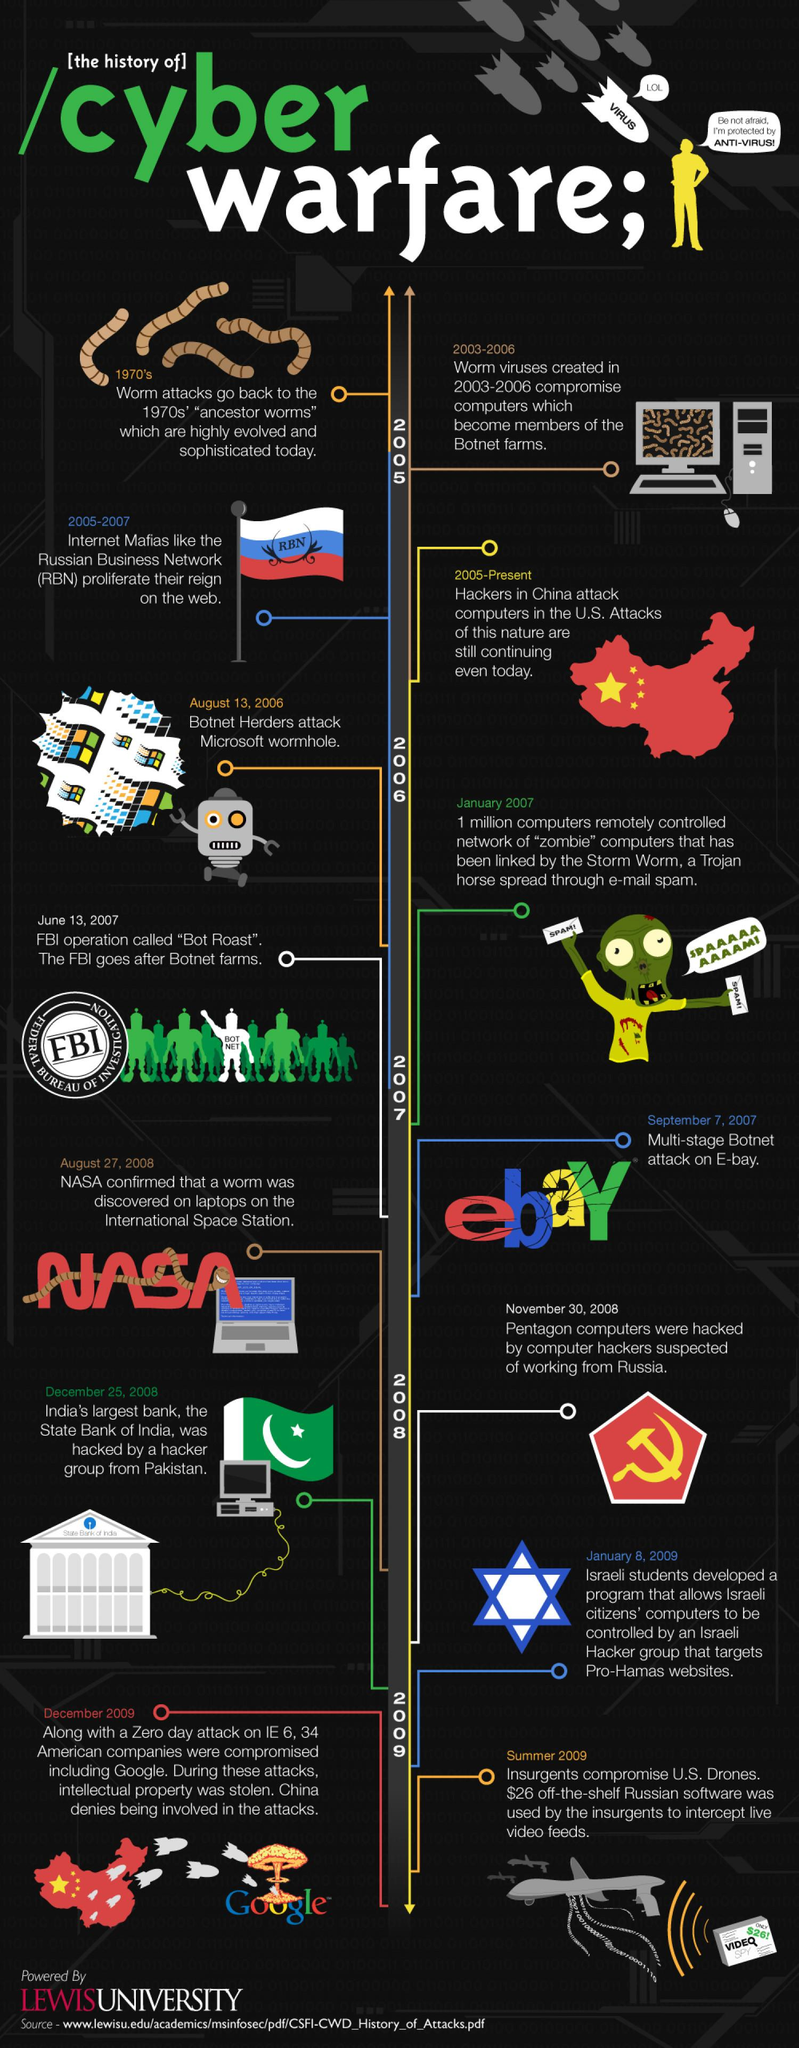Draw attention to some important aspects in this diagram. RBN proliferated on the web between 2005 and 2007. It has been established since 2005 that the Chinese have been attacking US computers. The FBI launched Operation "Bot Roast" on June 13, 2007. The Pentagon's computers were hacked on November 30, 2008. The Chinese government is suspected of launching cyber attacks against 34 American companies, including Google, in December 2009. 